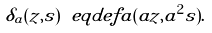<formula> <loc_0><loc_0><loc_500><loc_500>\delta _ { a } ( z , s ) \ e q d e f a ( a z , a ^ { 2 } s ) .</formula> 